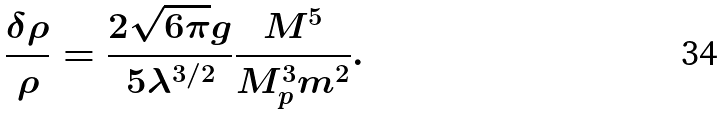Convert formula to latex. <formula><loc_0><loc_0><loc_500><loc_500>\frac { \delta \rho } { \rho } = \frac { 2 \sqrt { 6 \pi } g } { 5 \lambda ^ { 3 / 2 } } \frac { M ^ { 5 } } { M _ { p } ^ { 3 } m ^ { 2 } } .</formula> 